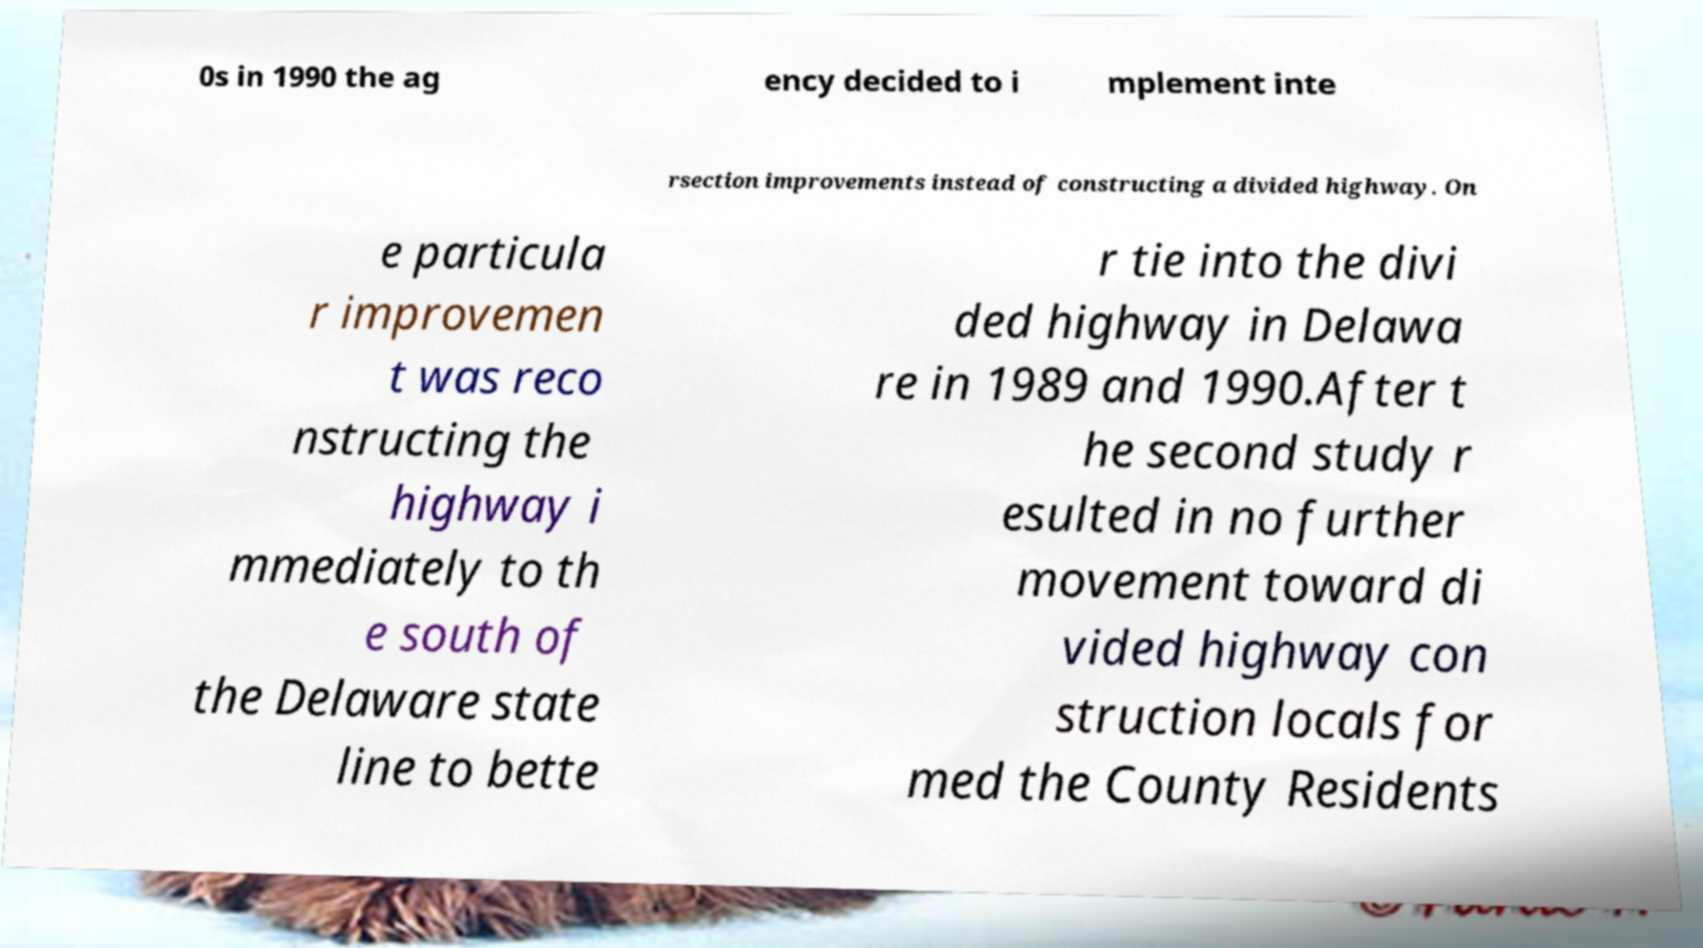There's text embedded in this image that I need extracted. Can you transcribe it verbatim? 0s in 1990 the ag ency decided to i mplement inte rsection improvements instead of constructing a divided highway. On e particula r improvemen t was reco nstructing the highway i mmediately to th e south of the Delaware state line to bette r tie into the divi ded highway in Delawa re in 1989 and 1990.After t he second study r esulted in no further movement toward di vided highway con struction locals for med the County Residents 